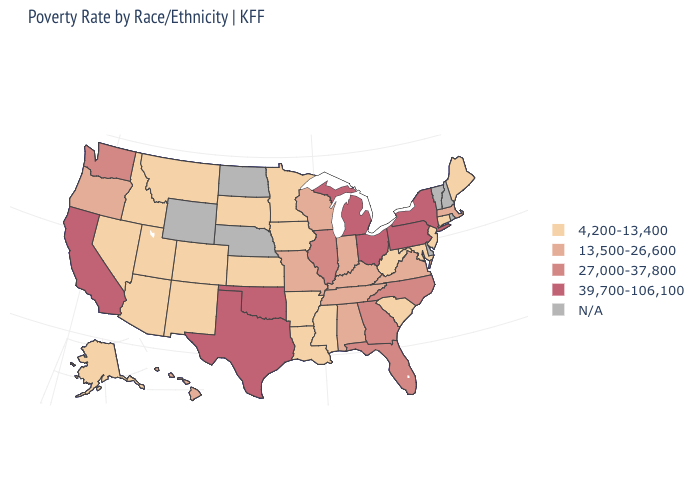Does the first symbol in the legend represent the smallest category?
Answer briefly. Yes. What is the value of North Dakota?
Answer briefly. N/A. Among the states that border Wyoming , which have the lowest value?
Write a very short answer. Colorado, Idaho, Montana, South Dakota, Utah. Name the states that have a value in the range 39,700-106,100?
Be succinct. California, Michigan, New York, Ohio, Oklahoma, Pennsylvania, Texas. What is the value of New Mexico?
Be succinct. 4,200-13,400. Name the states that have a value in the range 39,700-106,100?
Keep it brief. California, Michigan, New York, Ohio, Oklahoma, Pennsylvania, Texas. What is the highest value in the MidWest ?
Be succinct. 39,700-106,100. Name the states that have a value in the range N/A?
Give a very brief answer. Delaware, Nebraska, New Hampshire, North Dakota, Rhode Island, Vermont, Wyoming. Does New York have the highest value in the USA?
Write a very short answer. Yes. Does Connecticut have the lowest value in the Northeast?
Be succinct. Yes. Among the states that border Oregon , does California have the lowest value?
Give a very brief answer. No. What is the highest value in the USA?
Short answer required. 39,700-106,100. How many symbols are there in the legend?
Write a very short answer. 5. What is the lowest value in the USA?
Be succinct. 4,200-13,400. Name the states that have a value in the range 13,500-26,600?
Answer briefly. Alabama, Hawaii, Indiana, Kentucky, Massachusetts, Missouri, Oregon, Tennessee, Virginia, Wisconsin. 